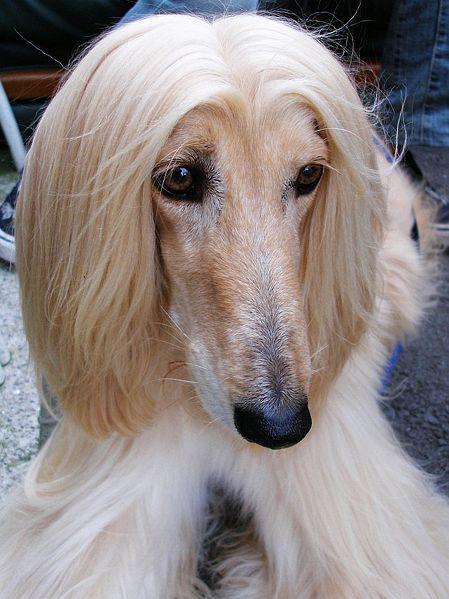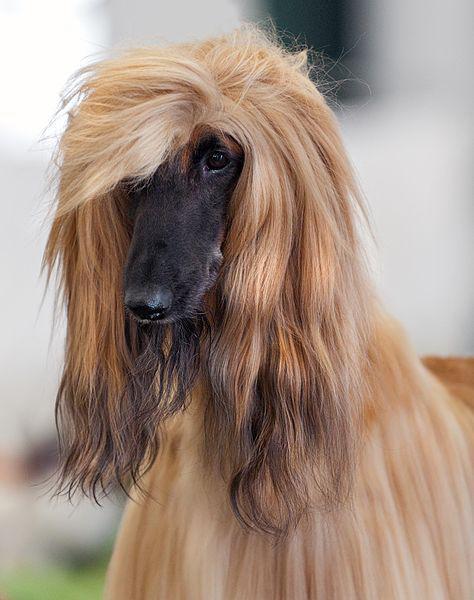The first image is the image on the left, the second image is the image on the right. For the images displayed, is the sentence "An image shows a reclining hound with its front paws extended in front of its body." factually correct? Answer yes or no. No. 